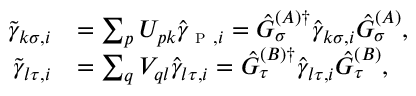<formula> <loc_0><loc_0><loc_500><loc_500>\begin{array} { r l } { \tilde { \gamma } _ { k \sigma , i } } & { = \sum _ { p } U _ { p k } \hat { \gamma } _ { p , i } = \hat { G } _ { \sigma } ^ { ( A ) \dagger } \hat { \gamma } _ { k \sigma , i } \hat { G } _ { \sigma } ^ { ( A ) } , } \\ { \tilde { \gamma } _ { l \tau , i } } & { = \sum _ { q } V _ { q l } \hat { \gamma } _ { l \tau , i } = \hat { G } _ { \tau } ^ { ( B ) \dagger } \hat { \gamma } _ { l \tau , i } \hat { G } _ { \tau } ^ { ( B ) } , } \end{array}</formula> 